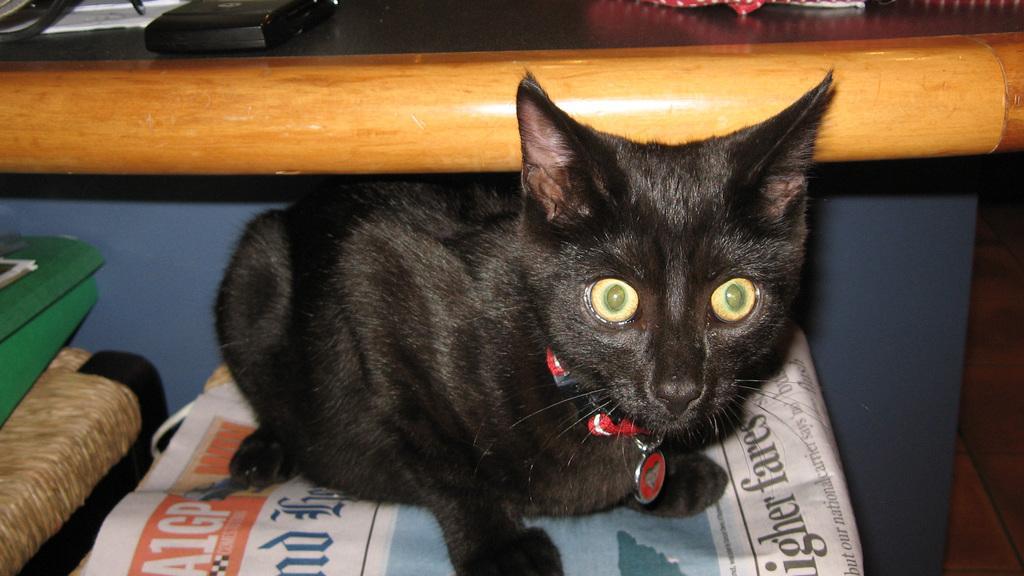In one or two sentences, can you explain what this image depicts? This image is taken indoors. In the background there is a wall and there is a table with a few things on it. On the left side of the image there is a stool and there are a few things. In the middle of the image there is a cat sitting on the newspaper. The cat is black in color. 